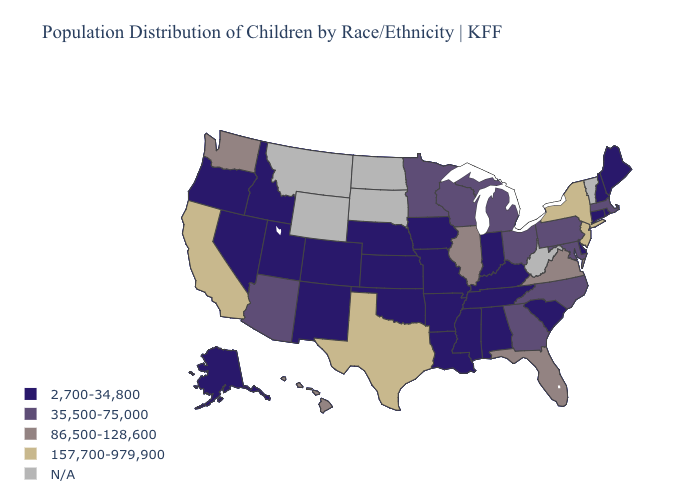What is the value of Arkansas?
Give a very brief answer. 2,700-34,800. Name the states that have a value in the range 157,700-979,900?
Short answer required. California, New Jersey, New York, Texas. Does Delaware have the lowest value in the USA?
Concise answer only. Yes. Among the states that border Florida , which have the lowest value?
Be succinct. Alabama. What is the value of Connecticut?
Answer briefly. 2,700-34,800. What is the lowest value in the USA?
Concise answer only. 2,700-34,800. Name the states that have a value in the range 2,700-34,800?
Keep it brief. Alabama, Alaska, Arkansas, Colorado, Connecticut, Delaware, Idaho, Indiana, Iowa, Kansas, Kentucky, Louisiana, Maine, Mississippi, Missouri, Nebraska, Nevada, New Hampshire, New Mexico, Oklahoma, Oregon, Rhode Island, South Carolina, Tennessee, Utah. What is the highest value in states that border North Dakota?
Be succinct. 35,500-75,000. Which states have the lowest value in the West?
Quick response, please. Alaska, Colorado, Idaho, Nevada, New Mexico, Oregon, Utah. Name the states that have a value in the range 86,500-128,600?
Quick response, please. Florida, Hawaii, Illinois, Virginia, Washington. What is the value of New Mexico?
Give a very brief answer. 2,700-34,800. What is the lowest value in the South?
Write a very short answer. 2,700-34,800. Does New Hampshire have the highest value in the Northeast?
Be succinct. No. Among the states that border Oklahoma , does Texas have the lowest value?
Quick response, please. No. 